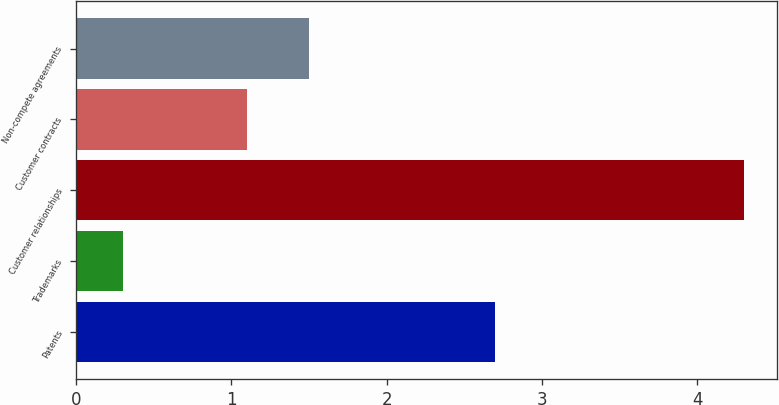Convert chart to OTSL. <chart><loc_0><loc_0><loc_500><loc_500><bar_chart><fcel>Patents<fcel>Trademarks<fcel>Customer relationships<fcel>Customer contracts<fcel>Non-compete agreements<nl><fcel>2.7<fcel>0.3<fcel>4.3<fcel>1.1<fcel>1.5<nl></chart> 